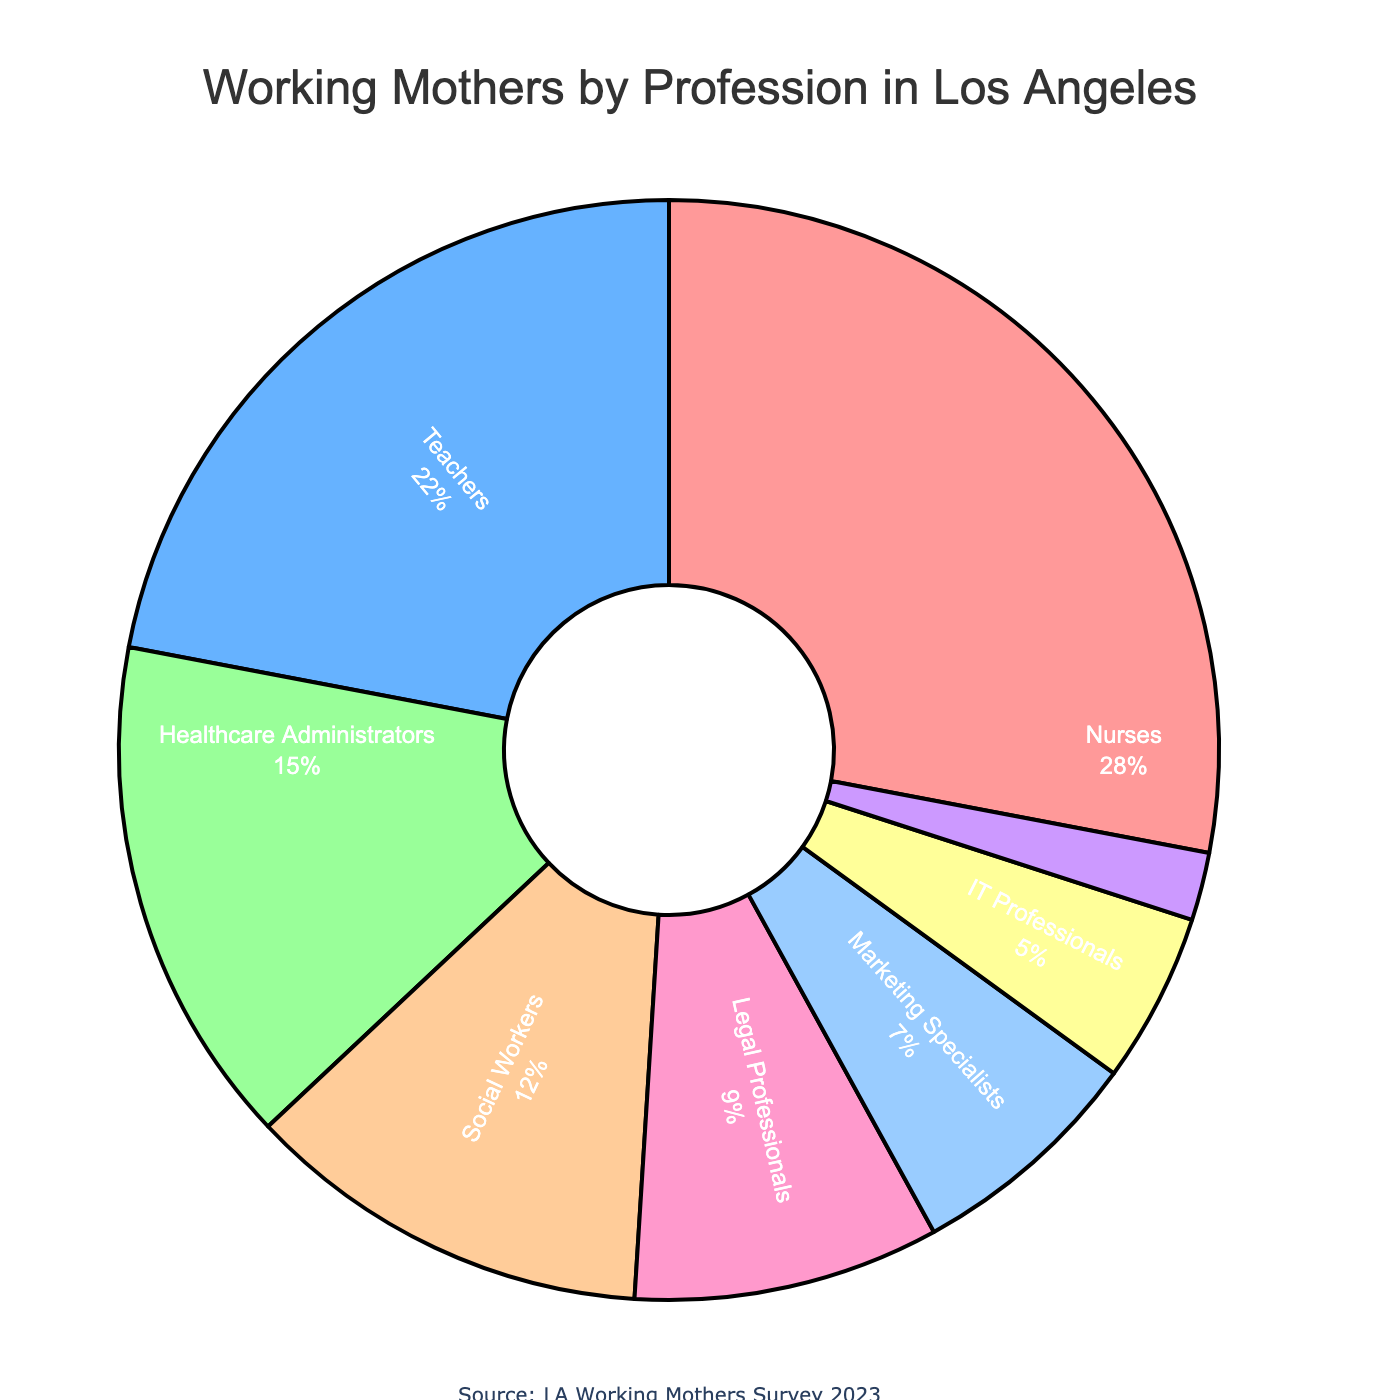What's the title of the figure? The title is usually at the top of the figure and provides a brief description of what the figure is about.
Answer: Working Mothers by Profession in Los Angeles What percentage of working mothers are nurses? Look for the segment labeled 'Nurses' in the pie chart and read the percentage displayed.
Answer: 28% Which two professions have the smallest percentage of working mothers? Identify the smallest segments in the pie chart by their labels and corresponding percentages.
Answer: Accountants (2%) and IT Professionals (5%) What is the total percentage of working mothers in social-oriented professions (Nurses, Social Workers, and Teachers)? Add the percentages of Nurses, Social Workers, and Teachers as labeled in the pie chart. 28% (Nurses) + 22% (Teachers) + 12% (Social Workers)
Answer: 62% How does the percentage of working mothers in legal professions compare to those in healthcare administration? Compare the percentage values next to the labels 'Legal Professionals' and 'Healthcare Administrators'.
Answer: Legal Professionals (9%) have a smaller percentage compared to Healthcare Administrators (15%) What color is used to represent marketing specialists on the pie chart? Observe the segment representing Marketing Specialists and identify its color.
Answer: Pink (#FF99CC) What is the combined percentage of working mothers in healthcare-related professions (Nurses and Healthcare Administrators)? Add the percentages of Nurses and Healthcare Administrators. 28% (Nurses) + 15% (Healthcare Administrators)
Answer: 43% Which profession has the highest percentage of working mothers? Identify the largest segment in the pie chart and read the label.
Answer: Nurses Is there more than twice the percentage of working mothers in social work compared to accounting? Compare the percentage of Social Workers (12%) to double the percentage of Accountants (2% × 2 = 4%).
Answer: Yes What is the percentage difference between teachers and marketing specialists? Subtract the percentage of Marketing Specialists from that of Teachers. 22% (Teachers) - 7% (Marketing Specialists)
Answer: 15% 